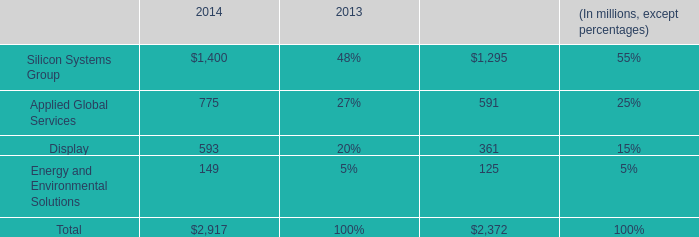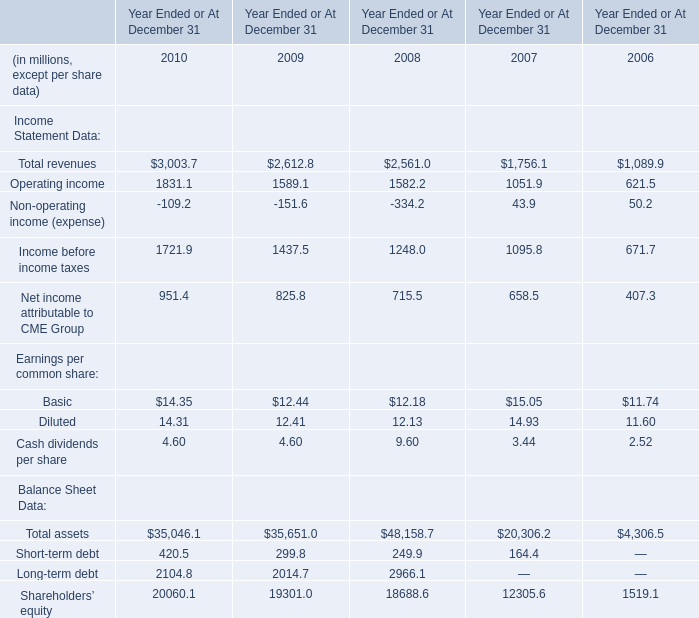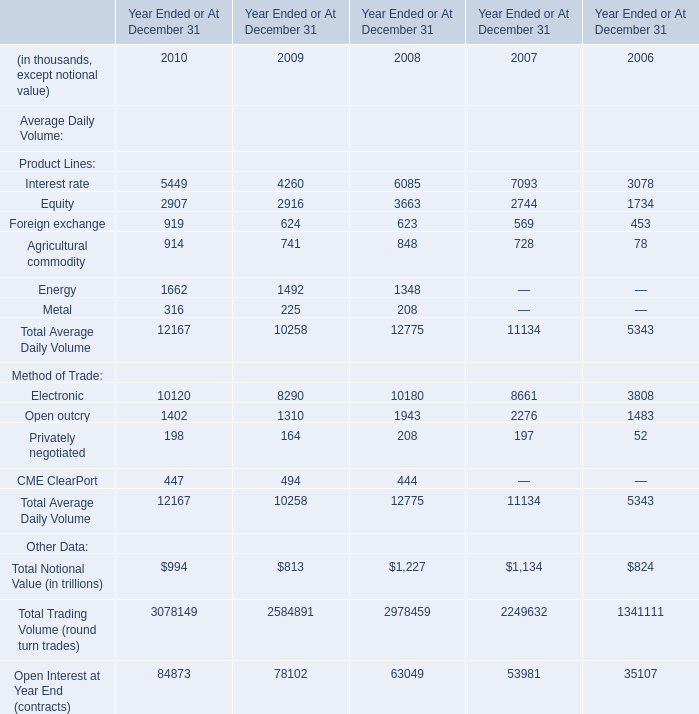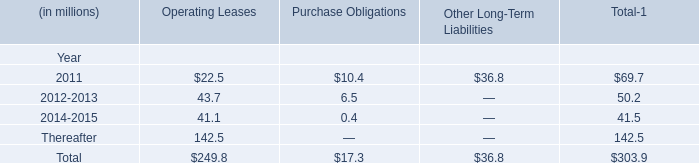What will Equity be like in 2011 if it develops with the same increasing rate as current? (in thousands) 
Computations: ((1 + ((2907 - 2916) / 2916)) * 2907)
Answer: 2898.02778. 